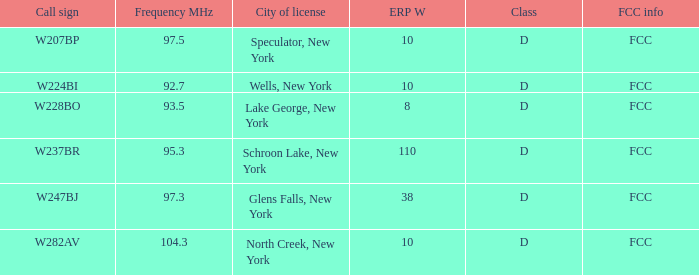Name the FCC info for frequency Mhz less than 97.3 and call sign of w237br FCC. 